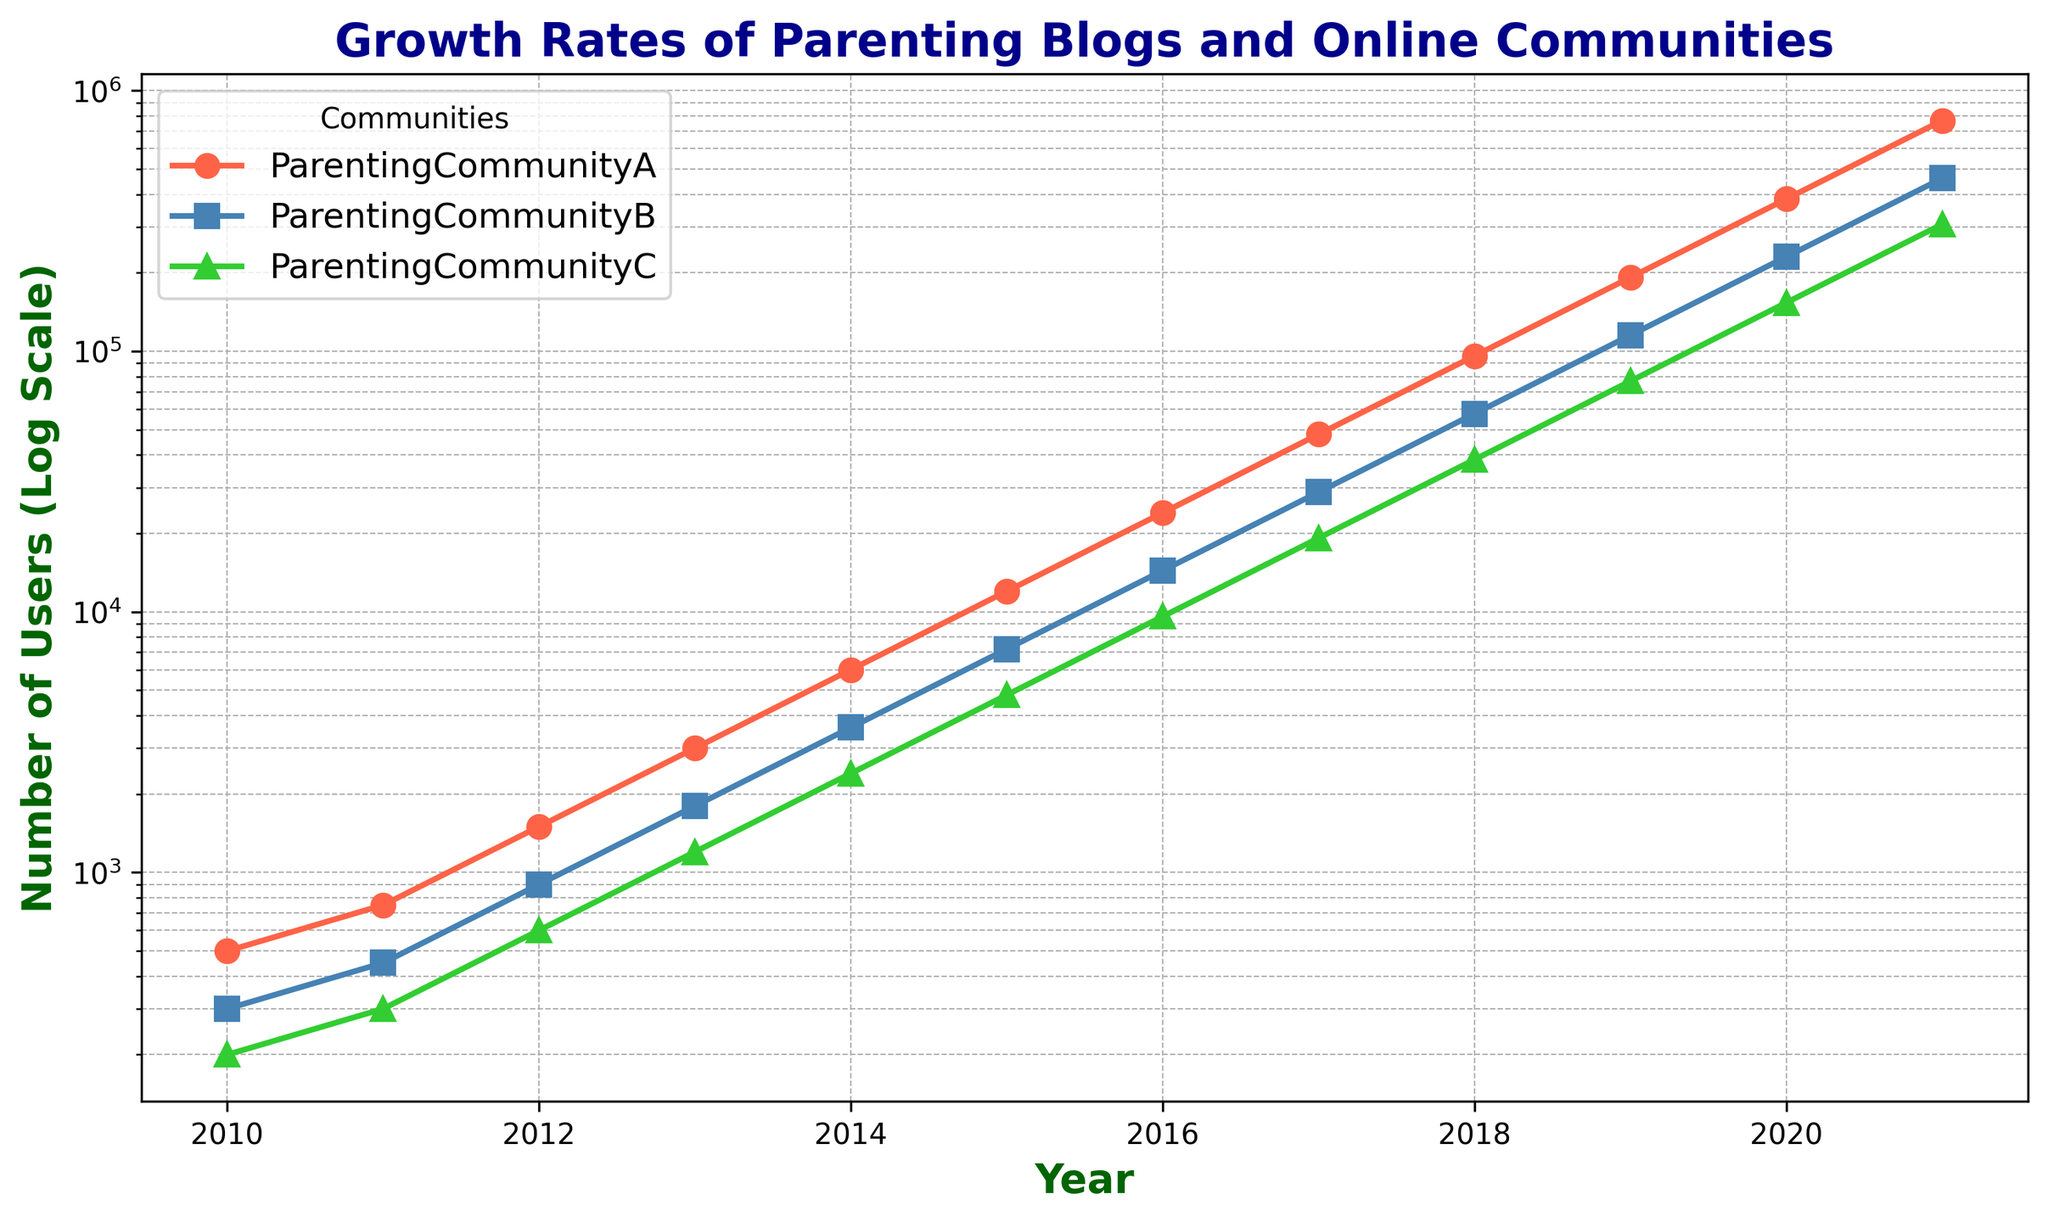What year did ParentingCommunityA reach 24,000 users? The graph shows the number of users for ParentingCommunityA on a log scale. According to the data, ParentingCommunityA reached 24,000 users in the year 2016.
Answer: 2016 Between ParentingCommunityB and ParentingCommunityC, which community had more users in 2013? By comparing the plotted points for 2013 for both communities, we see that ParentingCommunityB had 1,800 users, while ParentingCommunityC had 1,200 users.
Answer: ParentingCommunityB How many years did it take for ParentingCommunityA to grow from 3,000 to 12,000 users? ParentingCommunityA had about 3,000 users in 2013 and reached 12,000 users in 2015. Thus, it took 2 years (2015 - 2013) to grow from 3,000 to 12,000 users.
Answer: 2 years What is the growth factor for ParentingCommunityC from 2010 to 2021? ParentingCommunityC had 200 users in 2010 and 307,200 users in 2021. The growth factor is calculated by dividing the latter by the former: 307,200 / 200 = 1,536.
Answer: 1,536 Which community experienced the highest yearly growth in terms of raw user numbers between 2020 and 2021? By calculating the number of added users between 2020 and 2021 for each community: 
- ParentingCommunityA: 768,000 - 384,000 = 384,000 
- ParentingCommunityB: 460,800 - 230,400 = 230,400 
- ParentingCommunityC: 307,200 - 153,600 = 153,600 
Therefore, ParentingCommunityA experienced the highest yearly growth.
Answer: ParentingCommunityA What is the relative difference in user numbers between ParentingCommunityA and ParentingCommunityC in 2019? In 2019, ParentingCommunityA had 192,000 users and ParentingCommunityC had 76,800 users. The relative difference can be found by calculating (192,000 - 76,800) / 76,800, which equals approximately 1.5 or 150%.
Answer: 150% Are the growth trends of all communities exponentially increasing? Since all communities show a straight line in log scale on the plot, which indicates exponential growth trends over the years.
Answer: Yes How many more users did ParentingCommunityB have compared to ParentingCommunityC in 2017? In 2017, ParentingCommunityB had 28,800 users while ParentingCommunityC had 19,200 users. The difference is 28,800 - 19,200 = 9,600 users.
Answer: 9,600 What color represents ParentingCommunityB in the chart? By observing the plotted lines and their corresponding labels, we can see that ParentingCommunityB is represented by a blue line.
Answer: Blue 